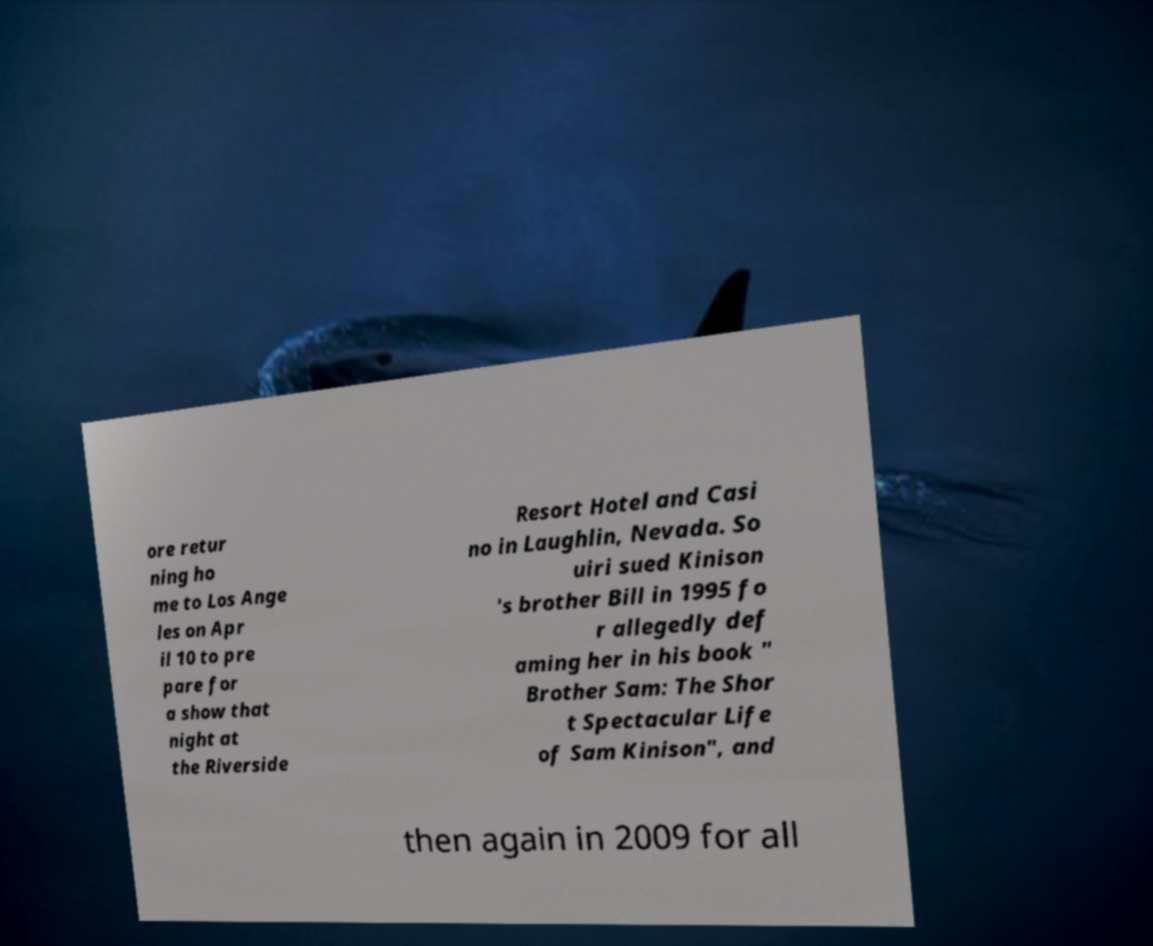Please identify and transcribe the text found in this image. ore retur ning ho me to Los Ange les on Apr il 10 to pre pare for a show that night at the Riverside Resort Hotel and Casi no in Laughlin, Nevada. So uiri sued Kinison 's brother Bill in 1995 fo r allegedly def aming her in his book " Brother Sam: The Shor t Spectacular Life of Sam Kinison", and then again in 2009 for all 